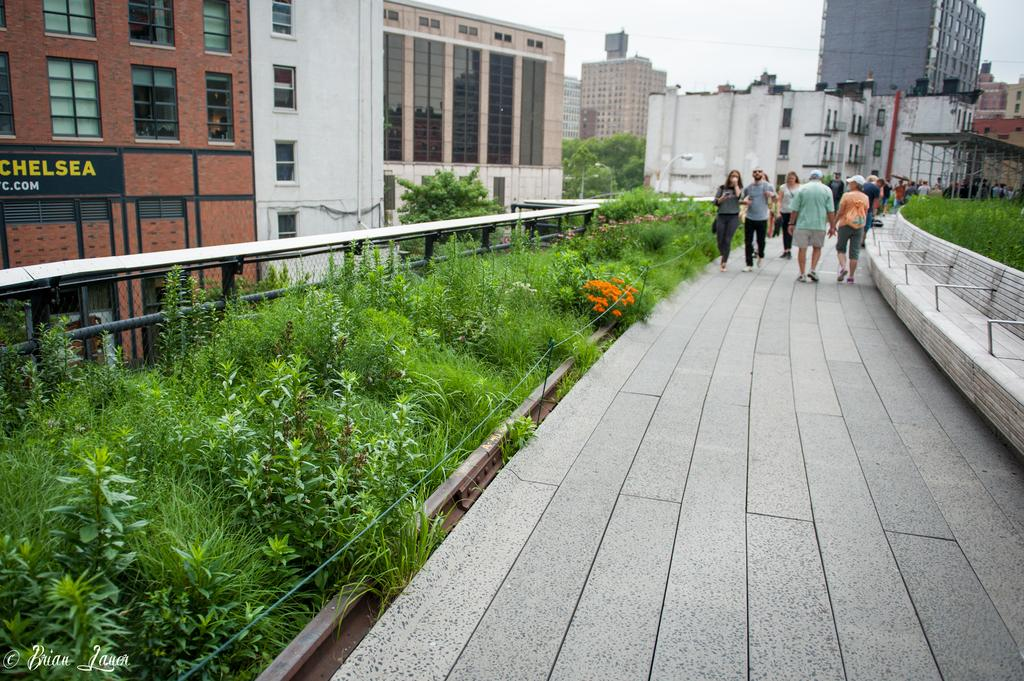What can be seen in the image? There is a group of men and women in the image. What are the people in the image doing? The group of people are walking on a pedestal area. What type of vegetation is present in the image? There are green plants in the image. What can be seen in the distance in the image? There are buildings in the background of the image. How many goldfish can be seen swimming in the image? There are no goldfish present in the image. What type of snake is visible in the image? There are no snakes present in the image. 